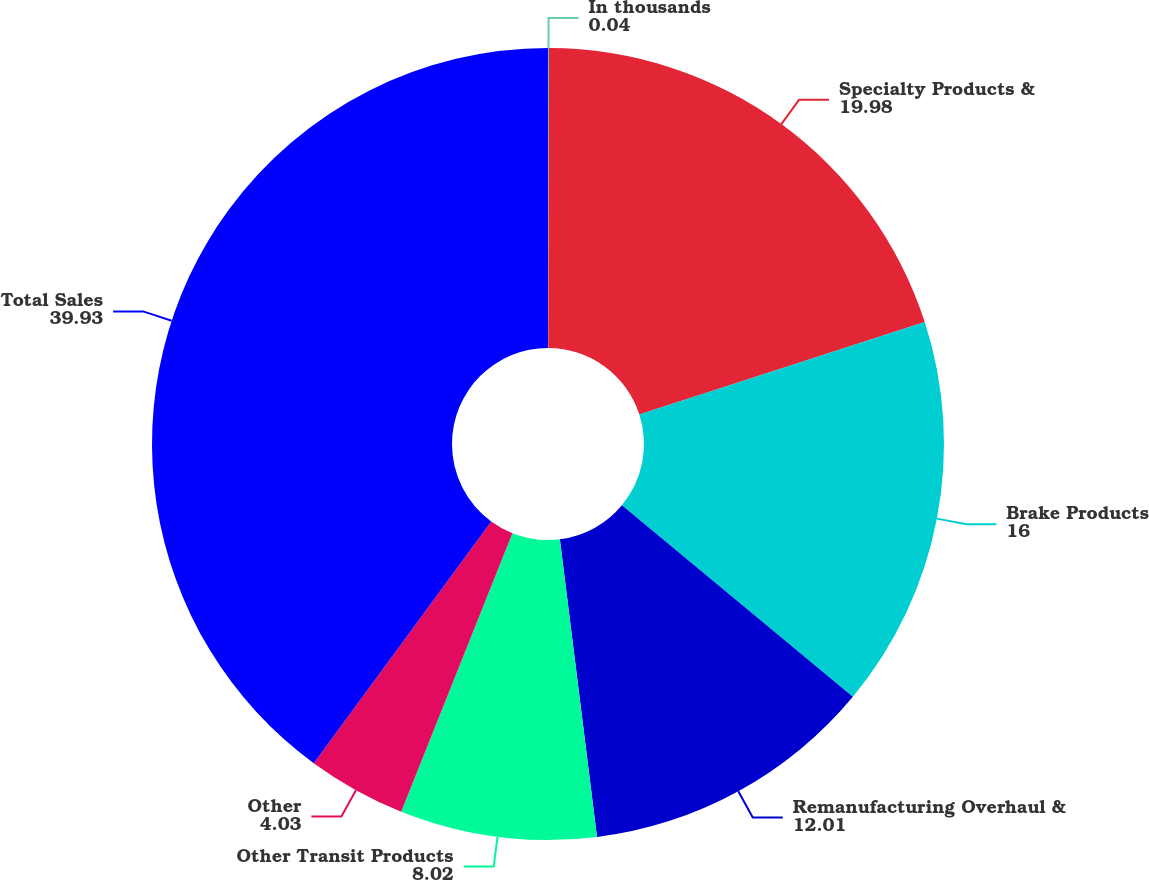Convert chart. <chart><loc_0><loc_0><loc_500><loc_500><pie_chart><fcel>In thousands<fcel>Specialty Products &<fcel>Brake Products<fcel>Remanufacturing Overhaul &<fcel>Other Transit Products<fcel>Other<fcel>Total Sales<nl><fcel>0.04%<fcel>19.98%<fcel>16.0%<fcel>12.01%<fcel>8.02%<fcel>4.03%<fcel>39.93%<nl></chart> 